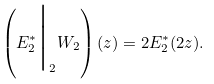Convert formula to latex. <formula><loc_0><loc_0><loc_500><loc_500>\left ( E _ { 2 } ^ { * } \Big | _ { 2 } W _ { 2 } \right ) ( z ) = 2 E _ { 2 } ^ { * } ( 2 z ) .</formula> 